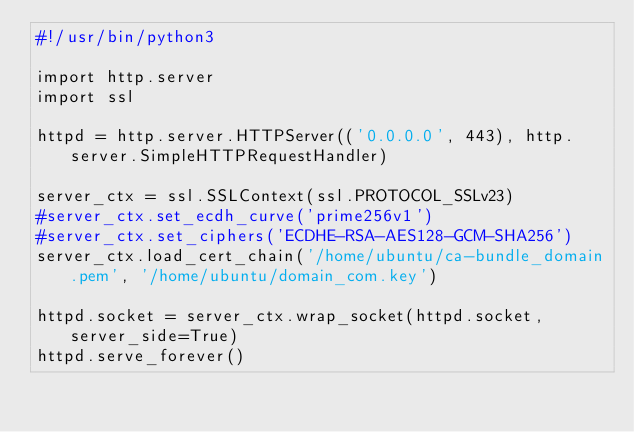<code> <loc_0><loc_0><loc_500><loc_500><_Bash_>#!/usr/bin/python3

import http.server
import ssl

httpd = http.server.HTTPServer(('0.0.0.0', 443), http.server.SimpleHTTPRequestHandler)

server_ctx = ssl.SSLContext(ssl.PROTOCOL_SSLv23)
#server_ctx.set_ecdh_curve('prime256v1')
#server_ctx.set_ciphers('ECDHE-RSA-AES128-GCM-SHA256')
server_ctx.load_cert_chain('/home/ubuntu/ca-bundle_domain.pem', '/home/ubuntu/domain_com.key')

httpd.socket = server_ctx.wrap_socket(httpd.socket, server_side=True)
httpd.serve_forever()
</code> 